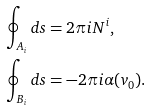Convert formula to latex. <formula><loc_0><loc_0><loc_500><loc_500>\oint _ { A _ { i } } d s & = 2 \pi i N ^ { i } , \\ \oint _ { B _ { i } } d s & = - 2 \pi i \alpha ( v _ { 0 } ) .</formula> 